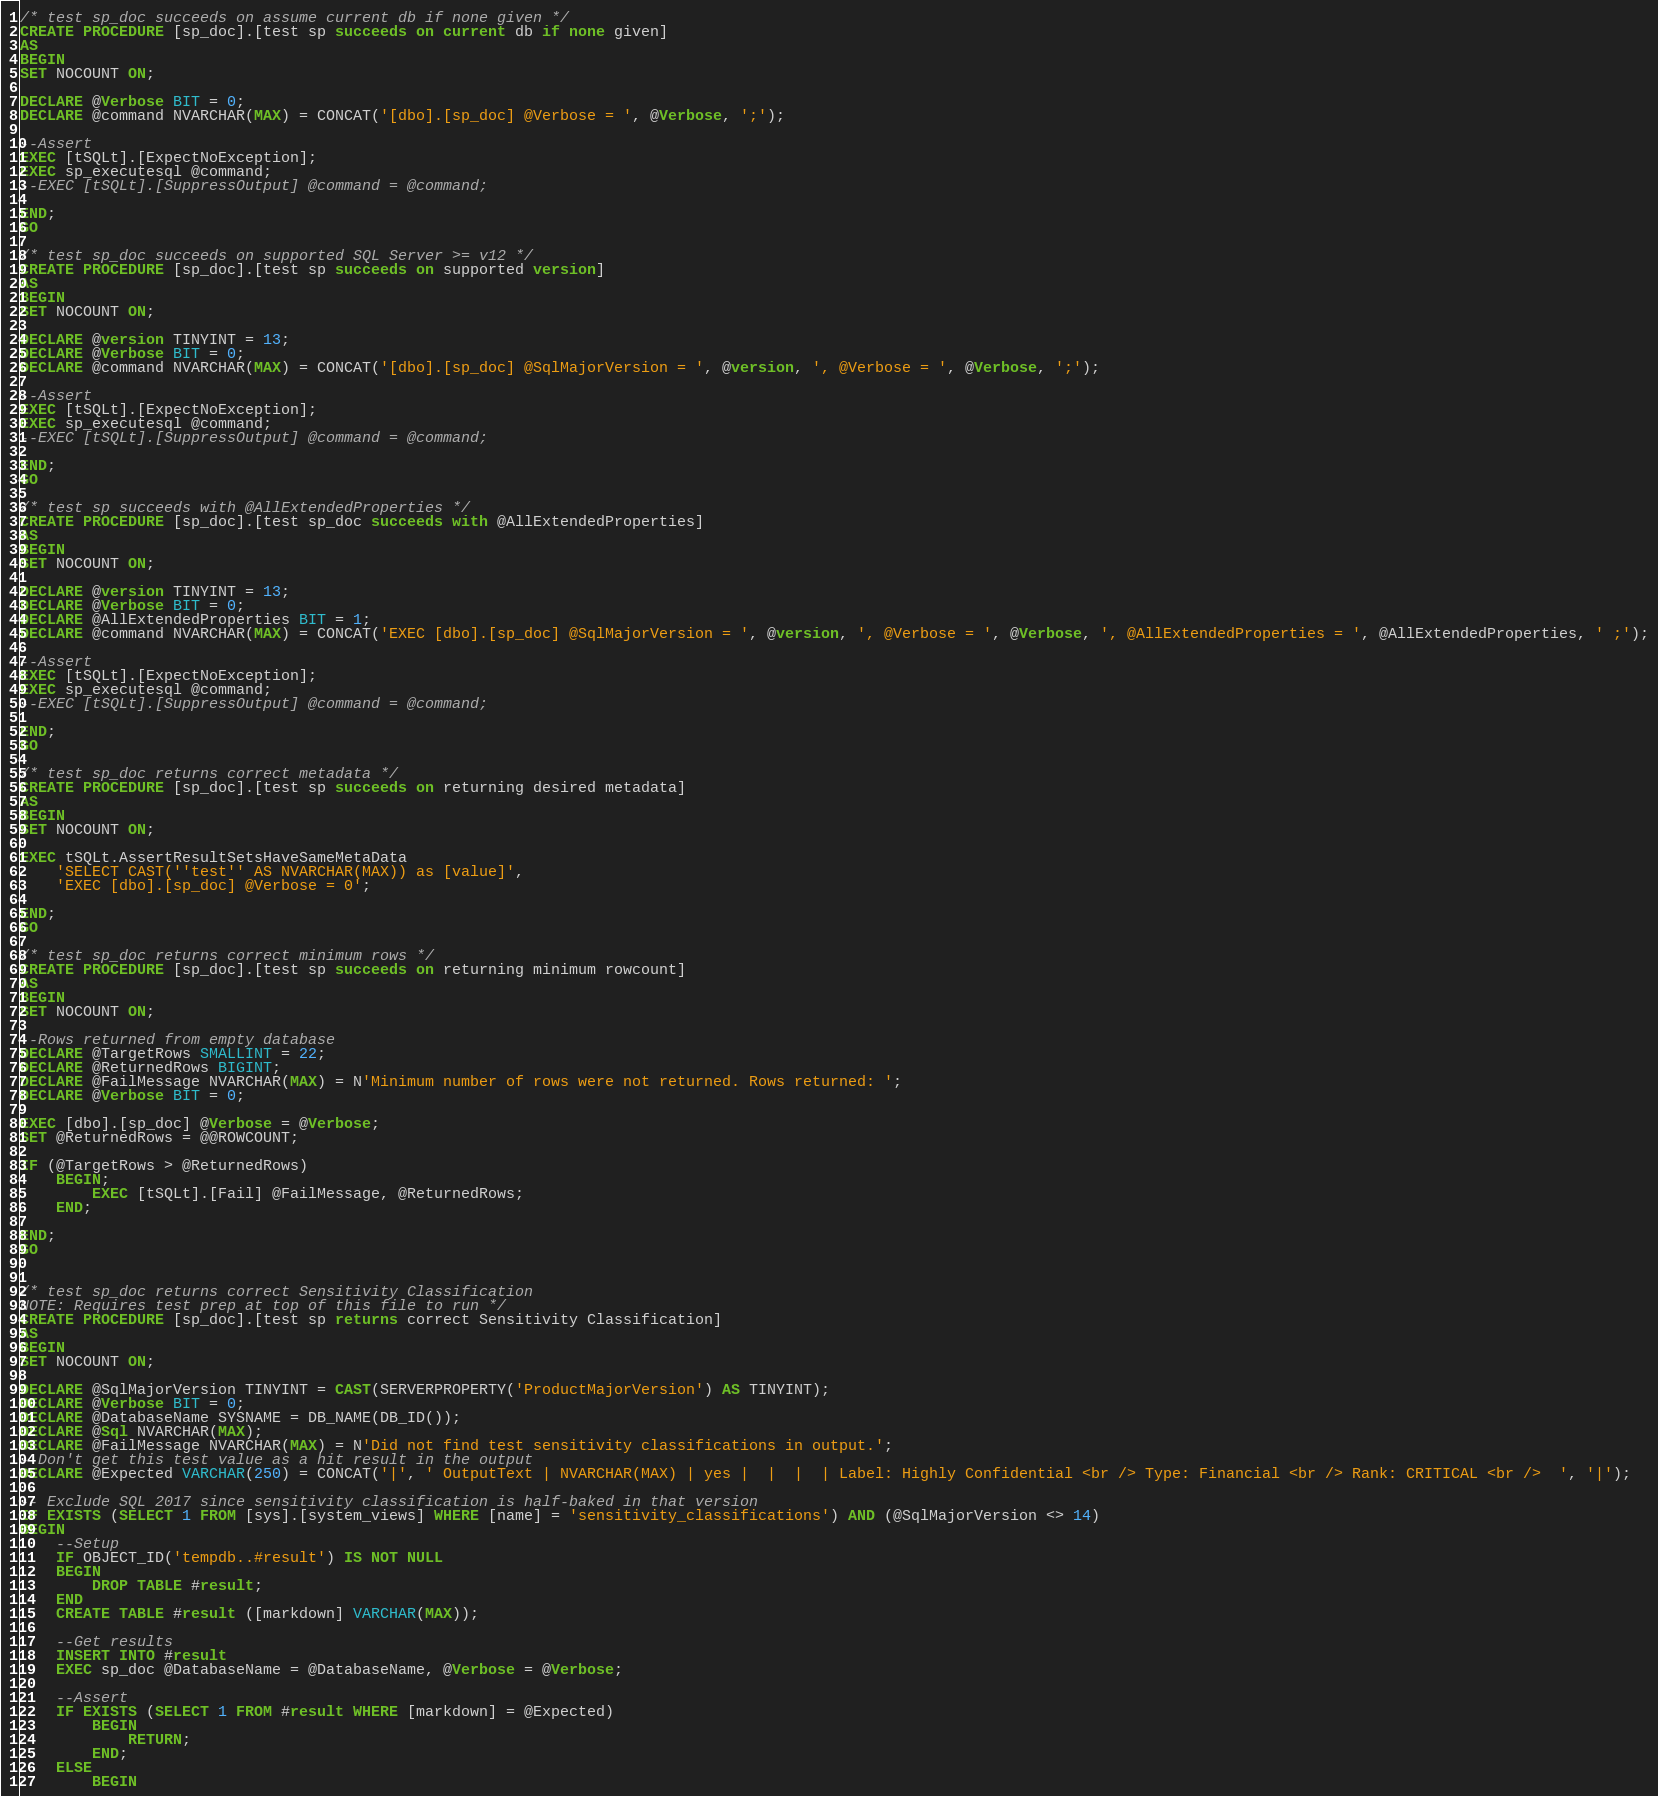<code> <loc_0><loc_0><loc_500><loc_500><_SQL_>
/* test sp_doc succeeds on assume current db if none given */
CREATE PROCEDURE [sp_doc].[test sp succeeds on current db if none given]
AS
BEGIN
SET NOCOUNT ON;

DECLARE @Verbose BIT = 0;
DECLARE @command NVARCHAR(MAX) = CONCAT('[dbo].[sp_doc] @Verbose = ', @Verbose, ';');

--Assert
EXEC [tSQLt].[ExpectNoException];
EXEC sp_executesql @command;
--EXEC [tSQLt].[SuppressOutput] @command = @command;

END;
GO

/* test sp_doc succeeds on supported SQL Server >= v12 */
CREATE PROCEDURE [sp_doc].[test sp succeeds on supported version]
AS
BEGIN
SET NOCOUNT ON;

DECLARE @version TINYINT = 13;
DECLARE @Verbose BIT = 0;
DECLARE @command NVARCHAR(MAX) = CONCAT('[dbo].[sp_doc] @SqlMajorVersion = ', @version, ', @Verbose = ', @Verbose, ';');

--Assert
EXEC [tSQLt].[ExpectNoException];
EXEC sp_executesql @command;
--EXEC [tSQLt].[SuppressOutput] @command = @command;

END;
GO

/* test sp succeeds with @AllExtendedProperties */
CREATE PROCEDURE [sp_doc].[test sp_doc succeeds with @AllExtendedProperties]
AS
BEGIN
SET NOCOUNT ON;

DECLARE @version TINYINT = 13;
DECLARE @Verbose BIT = 0;
DECLARE @AllExtendedProperties BIT = 1;
DECLARE @command NVARCHAR(MAX) = CONCAT('EXEC [dbo].[sp_doc] @SqlMajorVersion = ', @version, ', @Verbose = ', @Verbose, ', @AllExtendedProperties = ', @AllExtendedProperties, ' ;');

--Assert
EXEC [tSQLt].[ExpectNoException];
EXEC sp_executesql @command;
--EXEC [tSQLt].[SuppressOutput] @command = @command;

END;
GO

/* test sp_doc returns correct metadata */
CREATE PROCEDURE [sp_doc].[test sp succeeds on returning desired metadata]
AS
BEGIN
SET NOCOUNT ON;

EXEC tSQLt.AssertResultSetsHaveSameMetaData
    'SELECT CAST(''test'' AS NVARCHAR(MAX)) as [value]',
    'EXEC [dbo].[sp_doc] @Verbose = 0';

END;
GO

/* test sp_doc returns correct minimum rows */
CREATE PROCEDURE [sp_doc].[test sp succeeds on returning minimum rowcount]
AS
BEGIN
SET NOCOUNT ON;

--Rows returned from empty database
DECLARE @TargetRows SMALLINT = 22;
DECLARE @ReturnedRows BIGINT;
DECLARE @FailMessage NVARCHAR(MAX) = N'Minimum number of rows were not returned. Rows returned: ';
DECLARE @Verbose BIT = 0;

EXEC [dbo].[sp_doc] @Verbose = @Verbose;
SET @ReturnedRows = @@ROWCOUNT;

IF (@TargetRows > @ReturnedRows)
    BEGIN;
        EXEC [tSQLt].[Fail] @FailMessage, @ReturnedRows;
    END;

END;
GO


/* test sp_doc returns correct Sensitivity Classification
NOTE: Requires test prep at top of this file to run */
CREATE PROCEDURE [sp_doc].[test sp returns correct Sensitivity Classification]
AS
BEGIN
SET NOCOUNT ON;

DECLARE @SqlMajorVersion TINYINT = CAST(SERVERPROPERTY('ProductMajorVersion') AS TINYINT);
DECLARE @Verbose BIT = 0;
DECLARE @DatabaseName SYSNAME = DB_NAME(DB_ID());
DECLARE @Sql NVARCHAR(MAX);
DECLARE @FailMessage NVARCHAR(MAX) = N'Did not find test sensitivity classifications in output.';
--Don't get this test value as a hit result in the output
DECLARE @Expected VARCHAR(250) = CONCAT('|', ' OutputText | NVARCHAR(MAX) | yes |  |  |  | Label: Highly Confidential <br /> Type: Financial <br /> Rank: CRITICAL <br />  ', '|');

-- Exclude SQL 2017 since sensitivity classification is half-baked in that version
IF EXISTS (SELECT 1 FROM [sys].[system_views] WHERE [name] = 'sensitivity_classifications') AND (@SqlMajorVersion <> 14)
BEGIN
    --Setup
    IF OBJECT_ID('tempdb..#result') IS NOT NULL
    BEGIN
        DROP TABLE #result;
    END
    CREATE TABLE #result ([markdown] VARCHAR(MAX));

    --Get results
    INSERT INTO #result
    EXEC sp_doc @DatabaseName = @DatabaseName, @Verbose = @Verbose;

    --Assert
    IF EXISTS (SELECT 1 FROM #result WHERE [markdown] = @Expected)
        BEGIN
            RETURN;
        END;
    ELSE
        BEGIN</code> 